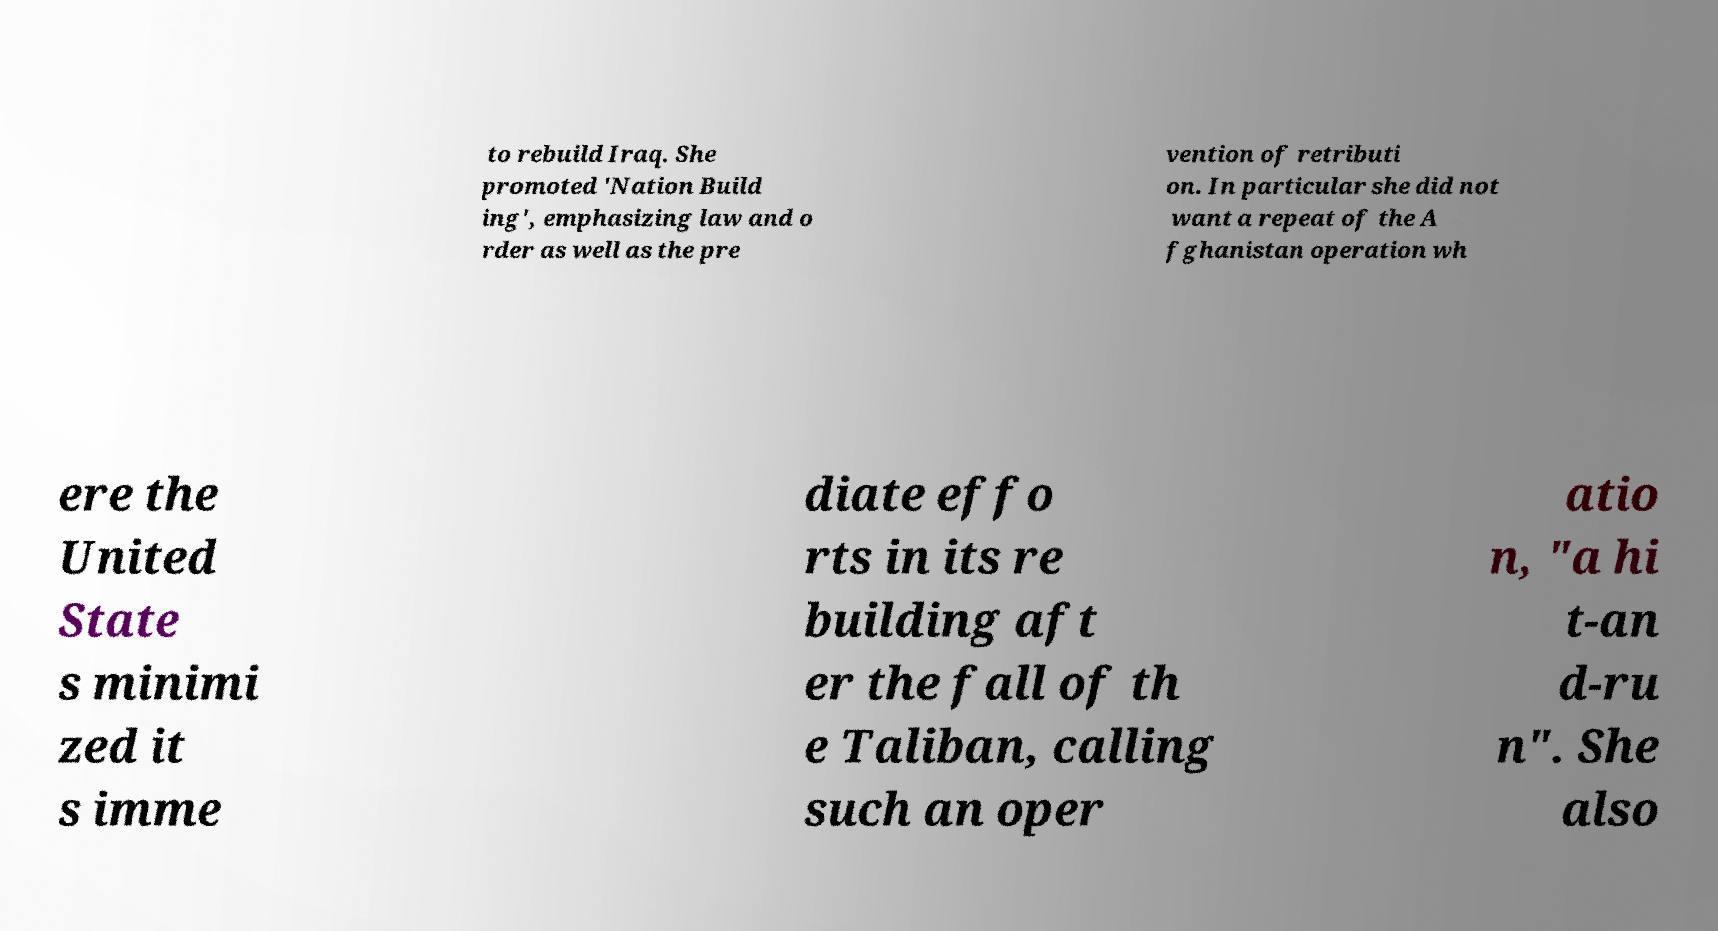I need the written content from this picture converted into text. Can you do that? to rebuild Iraq. She promoted 'Nation Build ing', emphasizing law and o rder as well as the pre vention of retributi on. In particular she did not want a repeat of the A fghanistan operation wh ere the United State s minimi zed it s imme diate effo rts in its re building aft er the fall of th e Taliban, calling such an oper atio n, "a hi t-an d-ru n". She also 